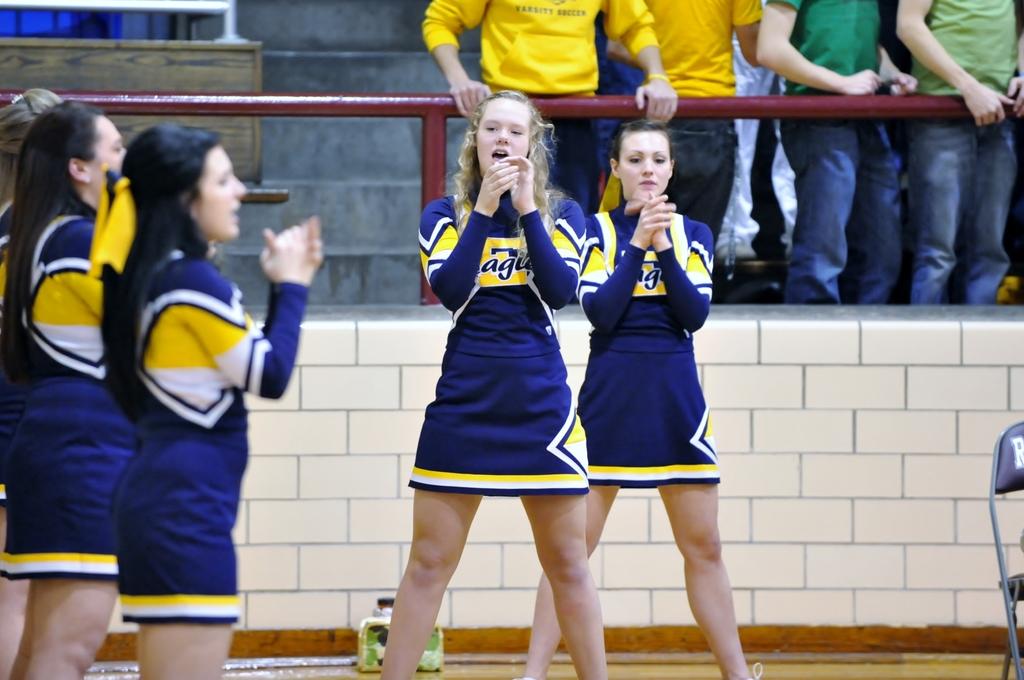What letters can you see on the girls' blouses?
Make the answer very short. Ag. 